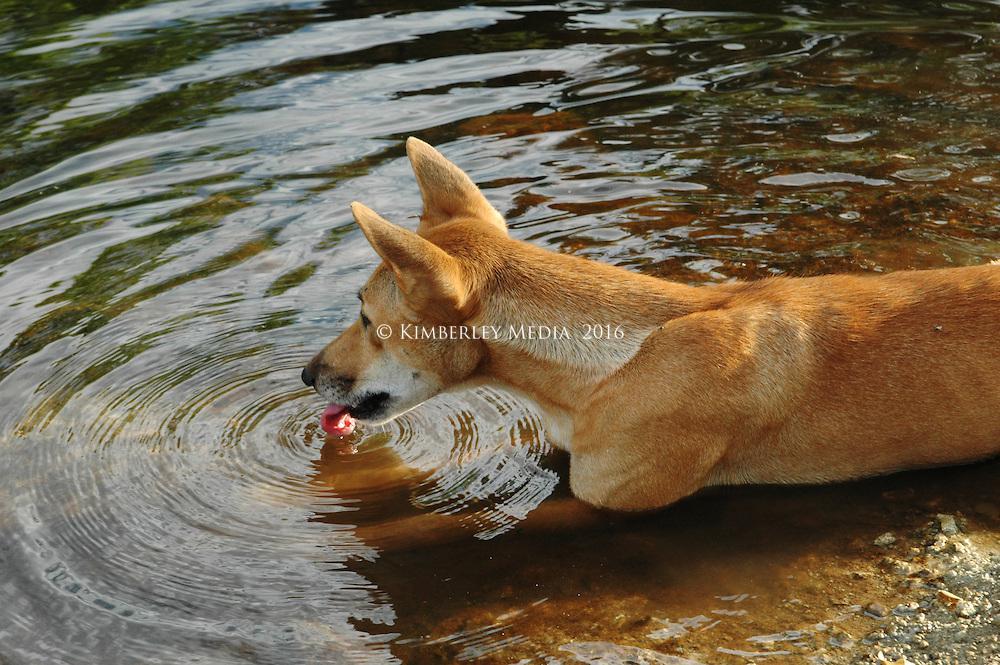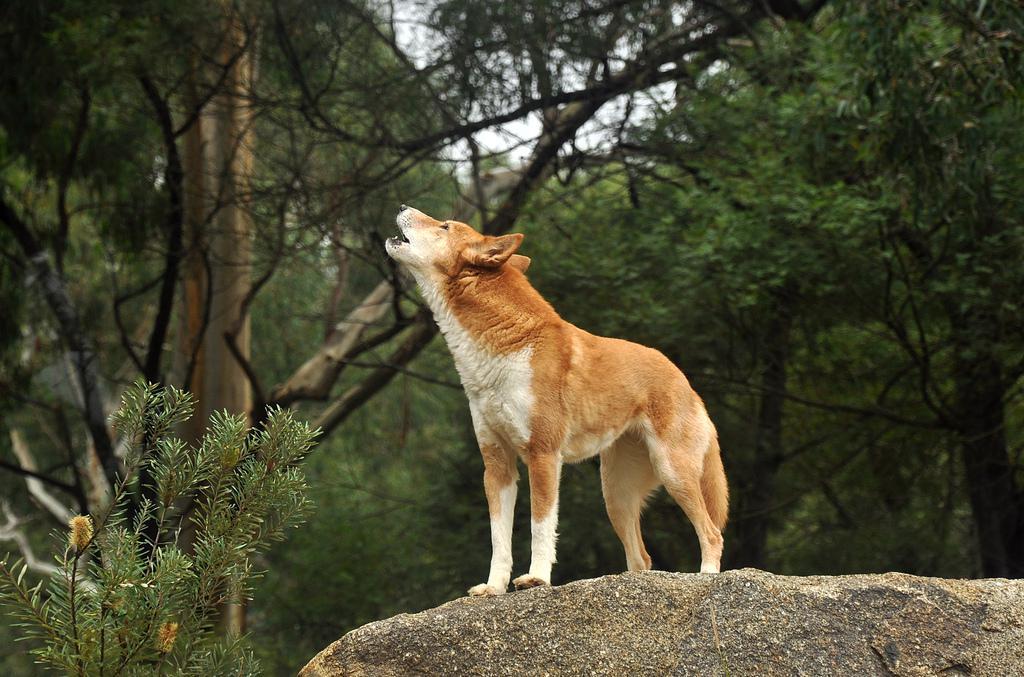The first image is the image on the left, the second image is the image on the right. Examine the images to the left and right. Is the description "Each image contains exactly one wild dog." accurate? Answer yes or no. Yes. 